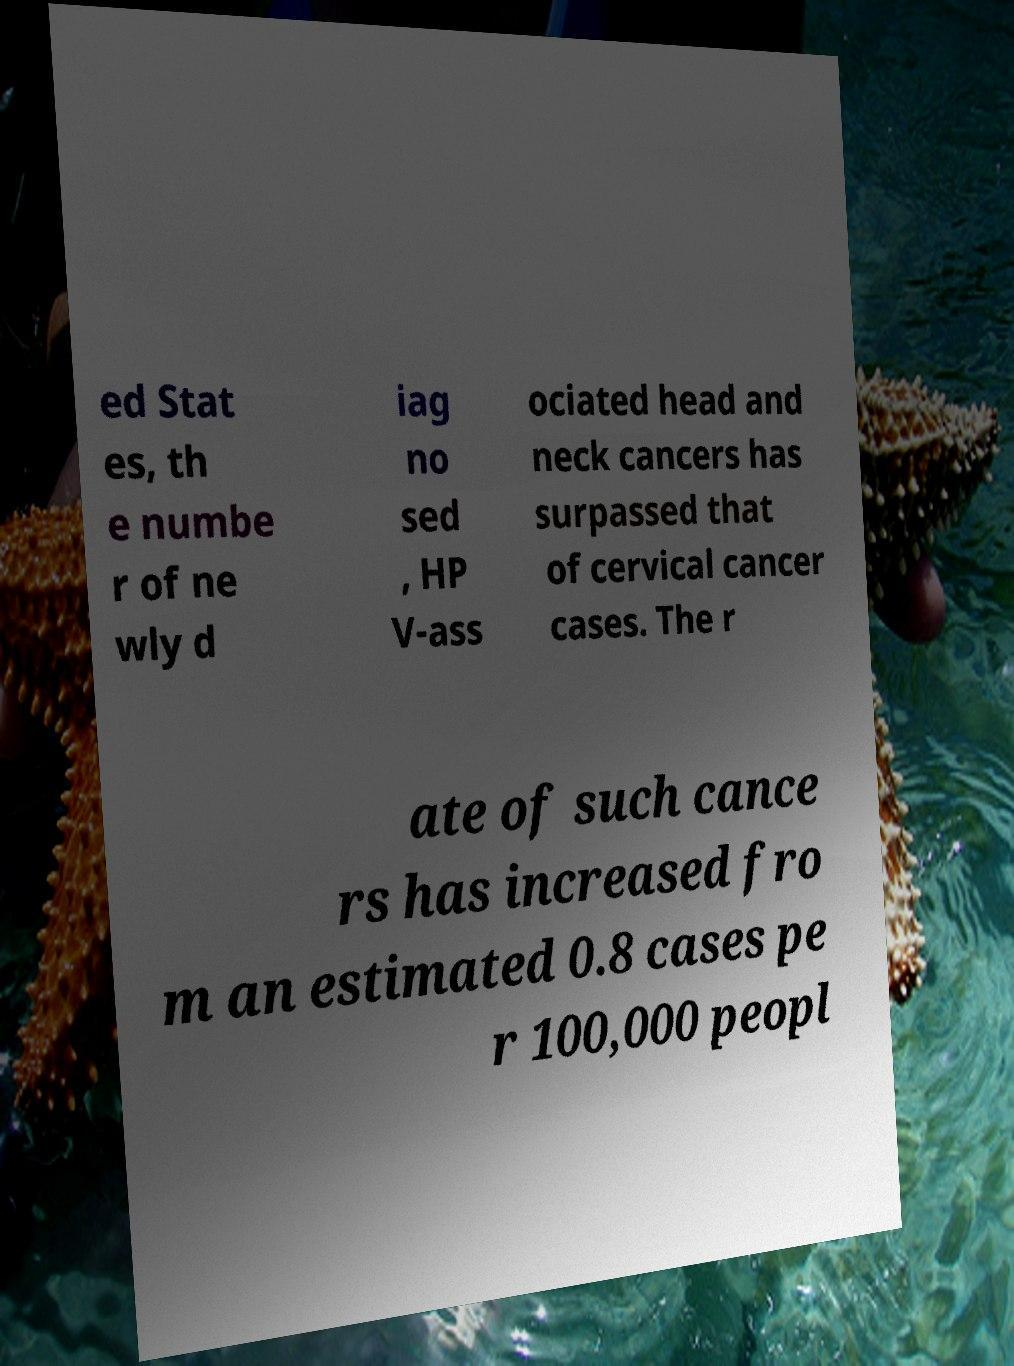What messages or text are displayed in this image? I need them in a readable, typed format. ed Stat es, th e numbe r of ne wly d iag no sed , HP V-ass ociated head and neck cancers has surpassed that of cervical cancer cases. The r ate of such cance rs has increased fro m an estimated 0.8 cases pe r 100,000 peopl 